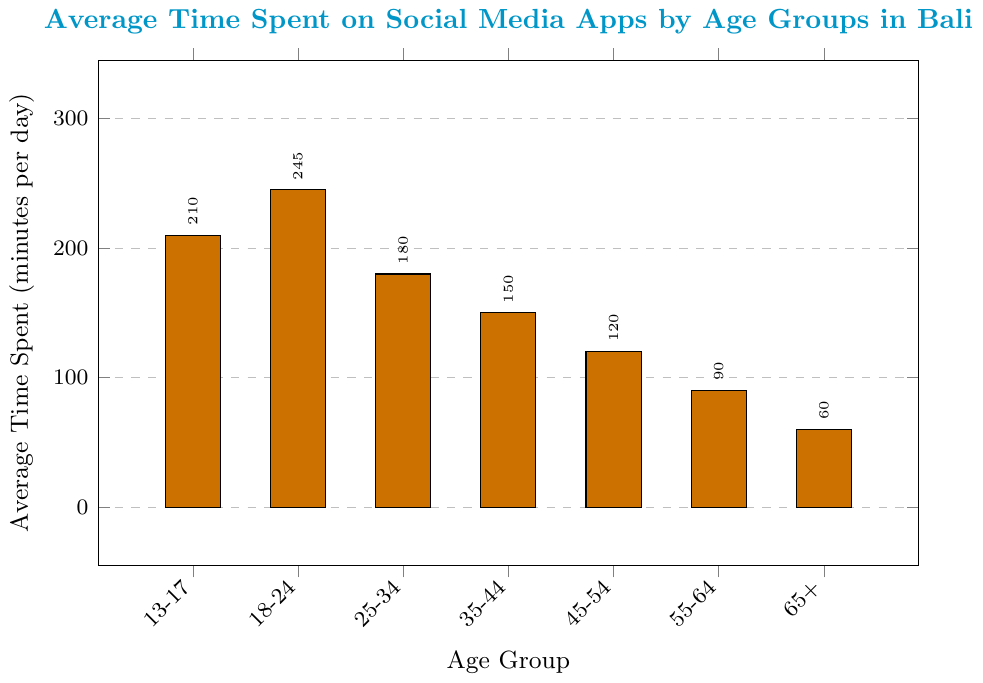Which age group spends the most time on social media apps? The figure shows that the bar for the 18-24 age group is the tallest, indicating they spend the most time on social media apps.
Answer: 18-24 Which age group spends the least time on social media apps? The figure shows that the bar for the 65+ age group is the shortest, indicating they spend the least time on social media apps.
Answer: 65+ How much more time do 13-17 year-olds spend on social media apps compared to 45-54 year-olds? From the figure, 13-17 year-olds spend 210 minutes per day, and 45-54 year-olds spend 120 minutes per day. The difference is 210 - 120 = 90 minutes.
Answer: 90 minutes What is the average time spent on social media apps across all age groups? The total time spent is the sum of all values: 210 + 245 + 180 + 150 + 120 + 90 + 60 = 1055 minutes. There are 7 age groups, so the average is 1055 / 7 ≈ 150.7 minutes.
Answer: ≈ 150.7 minutes Which age group spends more time on social media apps, 25-34 or 35-44? The figure shows that the bar for the 25-34 age group (180 minutes) is taller than the bar for the 35-44 age group (150 minutes).
Answer: 25-34 By how much does the average time spent decrease from the 18-24 to the 35-44 age group? The average time spent by the 18-24 age group is 245 minutes, and by the 35-44 age group is 150 minutes. The decrease is 245 - 150 = 95 minutes.
Answer: 95 minutes Which age group has a time spent closest to 2 hours per day? 2 hours per day equals 120 minutes. From the figure, the 45-54 age group spends 120 minutes per day, matching this value exactly.
Answer: 45-54 What is the median value of average time spent across all age groups? First, list all values in ascending order: 60, 90, 120, 150, 180, 210, 245. With 7 values, the median is the 4th value in this ordered list, which is 150 minutes.
Answer: 150 minutes How does the average time spent by the 55-64 age group compare to the time spent by the 18-24 age group? The 55-64 age group spends 90 minutes, while the 18-24 age group spends 245 minutes. The 18-24 age group spends 245 - 90 = 155 more minutes per day on social media.
Answer: 155 more minutes What is the total time spent on social media apps by the youngest and oldest age groups combined? The youngest age group (13-17) spends 210 minutes, and the oldest age group (65+) spends 60 minutes. Combined, they spend 210 + 60 = 270 minutes per day.
Answer: 270 minutes 